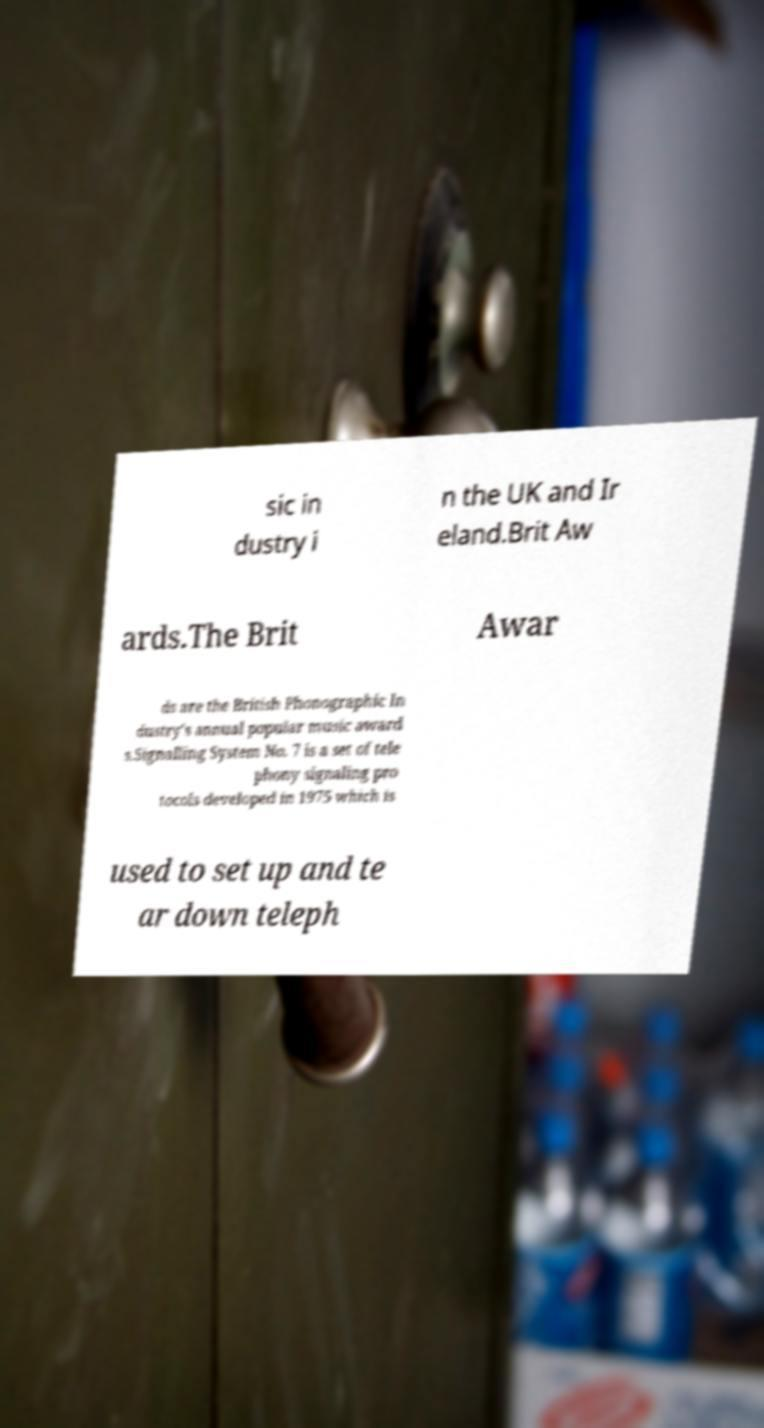What messages or text are displayed in this image? I need them in a readable, typed format. sic in dustry i n the UK and Ir eland.Brit Aw ards.The Brit Awar ds are the British Phonographic In dustry's annual popular music award s.Signalling System No. 7 is a set of tele phony signaling pro tocols developed in 1975 which is used to set up and te ar down teleph 